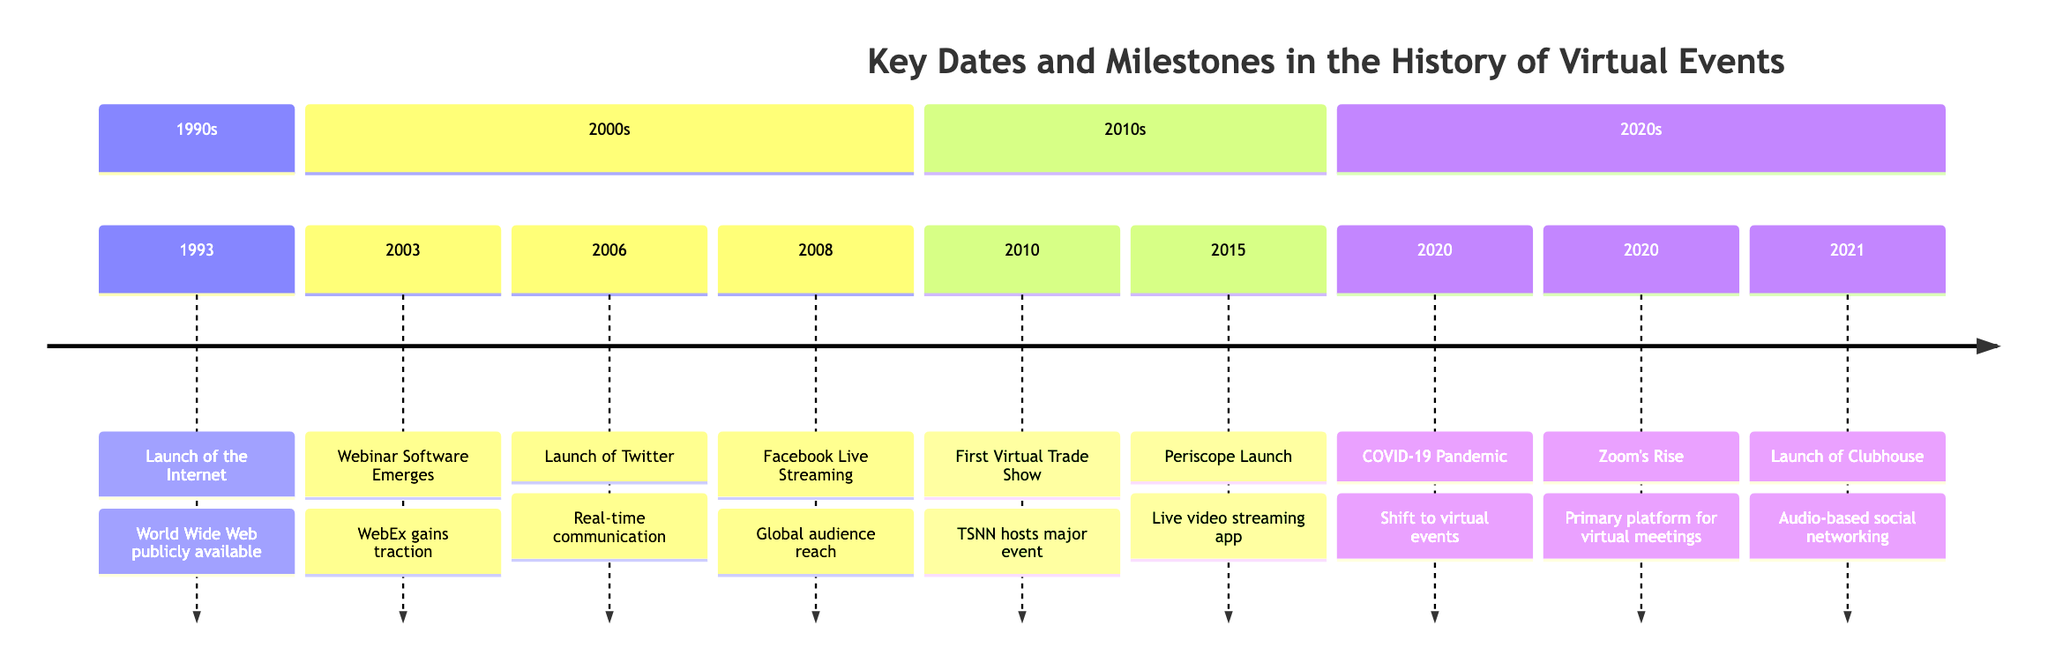What significant event took place on June 29, 1993? The milestone listed is the "Launch of the Internet," which marks the public availability of the World Wide Web.
Answer: Launch of the Internet How many key milestones are listed in the timeline? Counting the milestones, there are a total of eight key events included in the timeline.
Answer: 8 What milestone occurred in 2020 related to the pandemic? The relevant milestone is "COVID-19 Pandemic," which shifted the focus toward virtual events.
Answer: COVID-19 Pandemic Which platform launched on January 15, 2021? The milestone states “Launch of Clubhouse,” which is associated with audio-based virtual rooms.
Answer: Launch of Clubhouse What year did the first major virtual trade show occur? The timeline indicates that the "First Virtual Trade Show" took place in 2010.
Answer: 2010 Which two milestones are connected to real-time communication? The timeline shows that both "Launch of Twitter" in 2006 and "Periscope Launch" in 2015 are related to real-time communication and live interactions.
Answer: Launch of Twitter, Periscope Launch What was the main platform for virtual meetings during the pandemic? It states "Zoom's Rise to Prominence" which highlights Zoom becoming the primary platform.
Answer: Zoom's Rise to Prominence What significant technological development occurred in 2008? The "Facebook Introduces Live Streaming" event in 2008 allowed users to broadcast events live.
Answer: Facebook Introduces Live Streaming Which event set a precedent for the virtual event industry? The timeline mentions the "First Virtual Trade Show" as setting a precedent for future events in the industry.
Answer: First Virtual Trade Show 